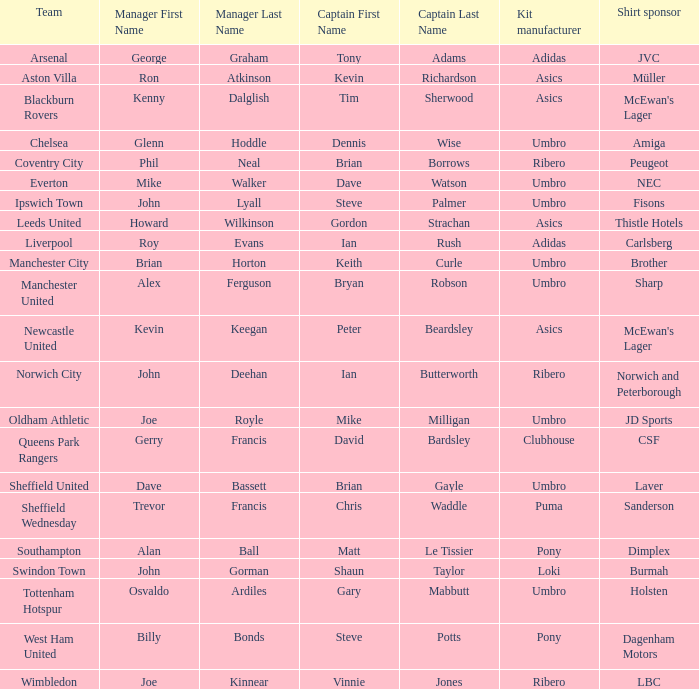What is the kit manufacturer that has billy bonds as the manager? Pony. 